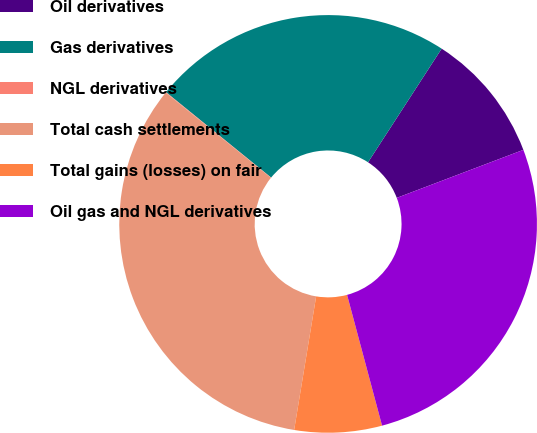Convert chart to OTSL. <chart><loc_0><loc_0><loc_500><loc_500><pie_chart><fcel>Oil derivatives<fcel>Gas derivatives<fcel>NGL derivatives<fcel>Total cash settlements<fcel>Total gains (losses) on fair<fcel>Oil gas and NGL derivatives<nl><fcel>10.08%<fcel>23.29%<fcel>0.04%<fcel>33.22%<fcel>6.76%<fcel>26.61%<nl></chart> 